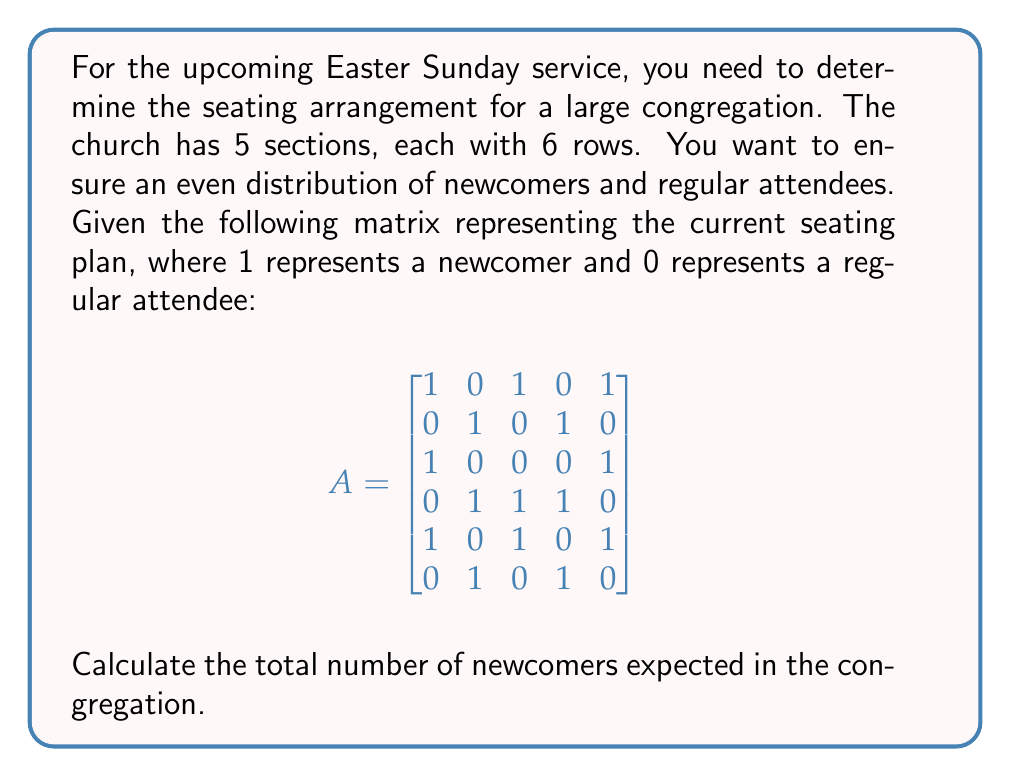Can you solve this math problem? To determine the total number of newcomers, we need to sum all the elements in the matrix A. This can be done by following these steps:

1. Count the number of 1's in each row:
   Row 1: 3
   Row 2: 2
   Row 3: 2
   Row 4: 3
   Row 5: 3
   Row 6: 2

2. Sum the counts from all rows:
   $3 + 2 + 2 + 3 + 3 + 2 = 15$

Alternatively, we can use the matrix trace property:

3. Create a 1x5 matrix of ones: $B = \begin{bmatrix} 1 & 1 & 1 & 1 & 1 \end{bmatrix}$

4. Multiply A and B:
   $C = A \cdot B^T = \begin{bmatrix} 3 \\ 2 \\ 2 \\ 3 \\ 3 \\ 2 \end{bmatrix}$

5. Sum the elements of C:
   $3 + 2 + 2 + 3 + 3 + 2 = 15$

Therefore, the total number of newcomers expected in the congregation is 15.
Answer: 15 newcomers 